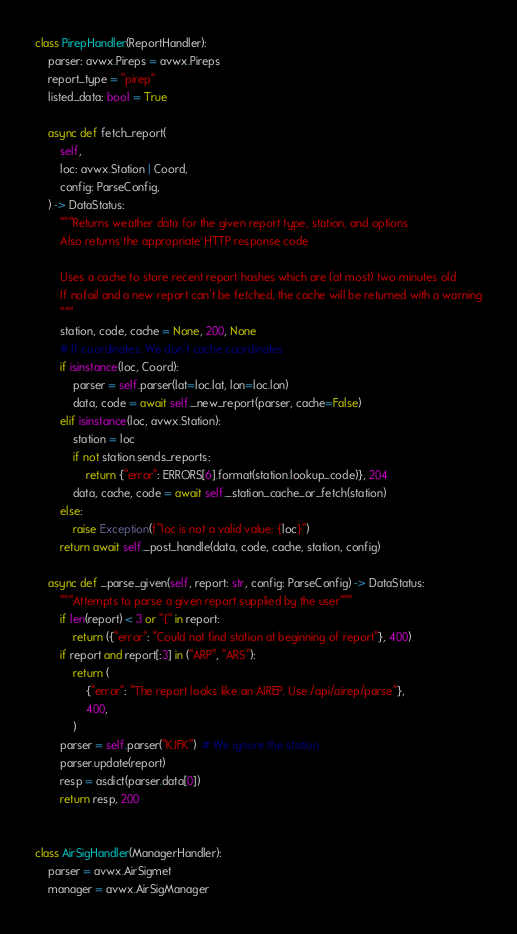<code> <loc_0><loc_0><loc_500><loc_500><_Python_>
class PirepHandler(ReportHandler):
    parser: avwx.Pireps = avwx.Pireps
    report_type = "pirep"
    listed_data: bool = True

    async def fetch_report(
        self,
        loc: avwx.Station | Coord,
        config: ParseConfig,
    ) -> DataStatus:
        """Returns weather data for the given report type, station, and options
        Also returns the appropriate HTTP response code

        Uses a cache to store recent report hashes which are (at most) two minutes old
        If nofail and a new report can't be fetched, the cache will be returned with a warning
        """
        station, code, cache = None, 200, None
        # If coordinates. We don't cache coordinates
        if isinstance(loc, Coord):
            parser = self.parser(lat=loc.lat, lon=loc.lon)
            data, code = await self._new_report(parser, cache=False)
        elif isinstance(loc, avwx.Station):
            station = loc
            if not station.sends_reports:
                return {"error": ERRORS[6].format(station.lookup_code)}, 204
            data, cache, code = await self._station_cache_or_fetch(station)
        else:
            raise Exception(f"loc is not a valid value: {loc}")
        return await self._post_handle(data, code, cache, station, config)

    async def _parse_given(self, report: str, config: ParseConfig) -> DataStatus:
        """Attempts to parse a given report supplied by the user"""
        if len(report) < 3 or "{" in report:
            return ({"error": "Could not find station at beginning of report"}, 400)
        if report and report[:3] in ("ARP", "ARS"):
            return (
                {"error": "The report looks like an AIREP. Use /api/airep/parse"},
                400,
            )
        parser = self.parser("KJFK")  # We ignore the station
        parser.update(report)
        resp = asdict(parser.data[0])
        return resp, 200


class AirSigHandler(ManagerHandler):
    parser = avwx.AirSigmet
    manager = avwx.AirSigManager
</code> 